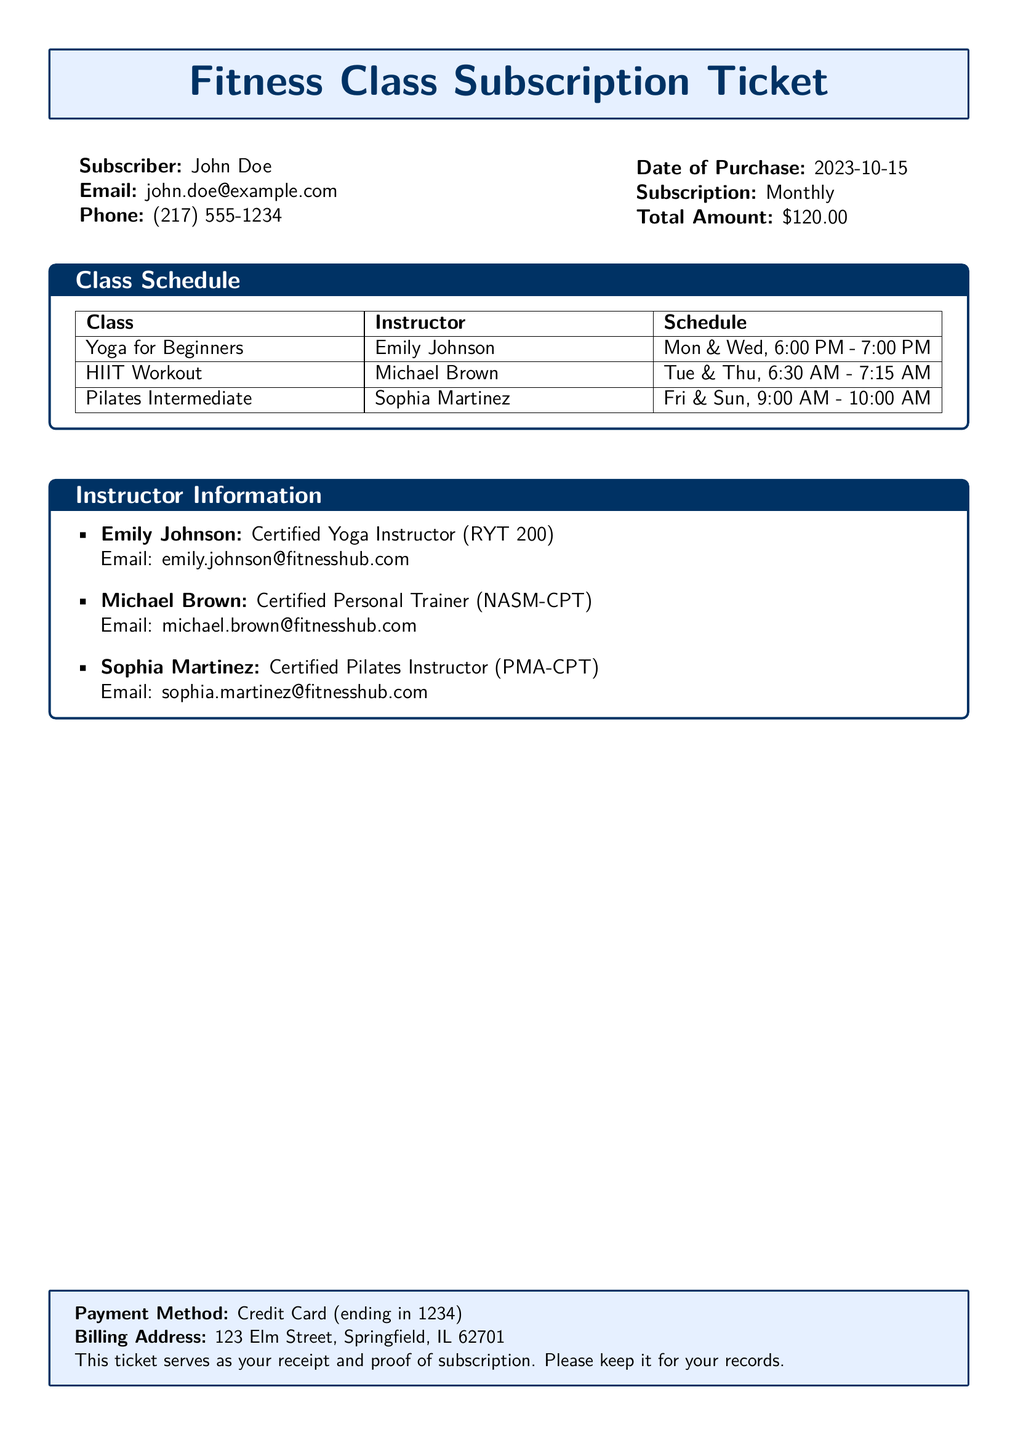What is the name of the subscriber? The document states the subscriber's name at the beginning, which is John Doe.
Answer: John Doe What is the total amount for the subscription? The total amount is clearly mentioned in the document under the purchase details as $120.00.
Answer: $120.00 Who is the instructor for the Yoga for Beginners class? The document lists the instructor for the Yoga for Beginners class as Emily Johnson.
Answer: Emily Johnson On which days does the HIIT Workout class take place? The schedule for the HIIT Workout class indicates it takes place on Tuesday and Thursday.
Answer: Tue & Thu What is Emily Johnson's email address? The document provides Emily Johnson's email address under Instructor Information which is emily.johnson@fitnesshub.com.
Answer: emily.johnson@fitnesshub.com How many classes are listed in the schedule? The document contains a section where the schedule is presented, listing a total of three classes.
Answer: Three What is the length of the HIIT Workout class? The schedule specifies that the HIIT Workout class lasts for 45 minutes from 6:30 AM to 7:15 AM.
Answer: 45 minutes What type of subscription did John Doe purchase? The subscription type is specified as Monthly in the purchase details.
Answer: Monthly What is the payment method used for the subscription? The payment method is described at the bottom of the document as Credit Card ending in 1234.
Answer: Credit Card (ending in 1234) 